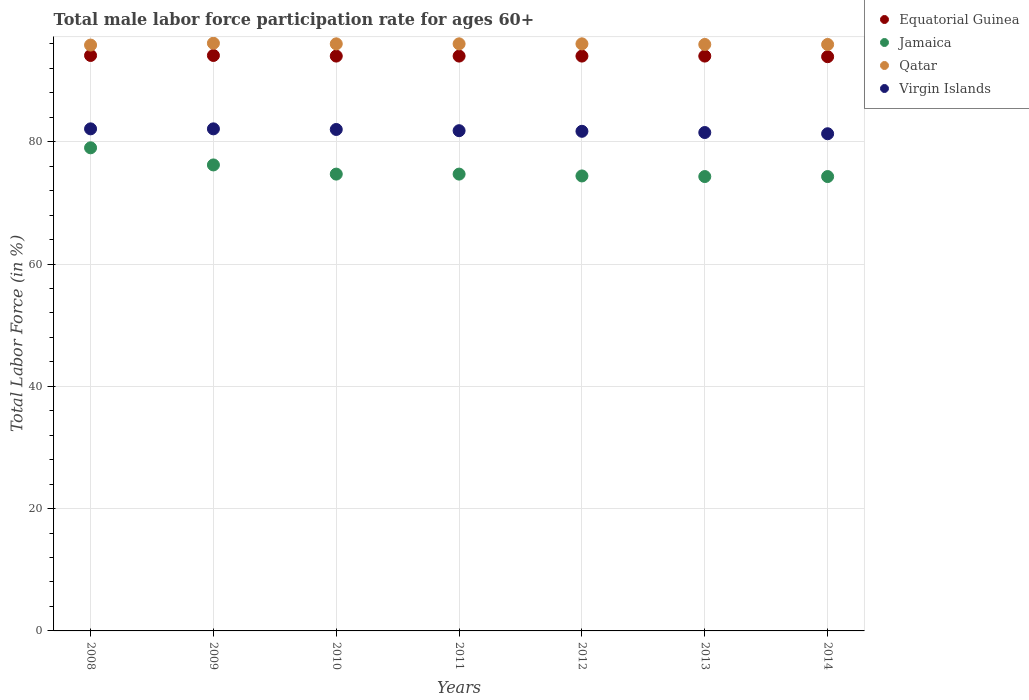How many different coloured dotlines are there?
Ensure brevity in your answer.  4. Is the number of dotlines equal to the number of legend labels?
Provide a short and direct response. Yes. What is the male labor force participation rate in Jamaica in 2013?
Your response must be concise. 74.3. Across all years, what is the maximum male labor force participation rate in Virgin Islands?
Offer a terse response. 82.1. Across all years, what is the minimum male labor force participation rate in Qatar?
Offer a very short reply. 95.8. In which year was the male labor force participation rate in Virgin Islands maximum?
Your answer should be very brief. 2008. What is the total male labor force participation rate in Qatar in the graph?
Offer a very short reply. 671.7. What is the difference between the male labor force participation rate in Virgin Islands in 2009 and that in 2011?
Keep it short and to the point. 0.3. What is the difference between the male labor force participation rate in Equatorial Guinea in 2014 and the male labor force participation rate in Jamaica in 2008?
Make the answer very short. 14.9. What is the average male labor force participation rate in Virgin Islands per year?
Make the answer very short. 81.79. What is the ratio of the male labor force participation rate in Qatar in 2008 to that in 2011?
Offer a very short reply. 1. What is the difference between the highest and the second highest male labor force participation rate in Jamaica?
Provide a short and direct response. 2.8. What is the difference between the highest and the lowest male labor force participation rate in Jamaica?
Give a very brief answer. 4.7. Is it the case that in every year, the sum of the male labor force participation rate in Qatar and male labor force participation rate in Equatorial Guinea  is greater than the sum of male labor force participation rate in Jamaica and male labor force participation rate in Virgin Islands?
Provide a short and direct response. Yes. Is it the case that in every year, the sum of the male labor force participation rate in Qatar and male labor force participation rate in Virgin Islands  is greater than the male labor force participation rate in Jamaica?
Your response must be concise. Yes. Is the male labor force participation rate in Equatorial Guinea strictly greater than the male labor force participation rate in Jamaica over the years?
Ensure brevity in your answer.  Yes. Is the male labor force participation rate in Virgin Islands strictly less than the male labor force participation rate in Jamaica over the years?
Your response must be concise. No. How many years are there in the graph?
Give a very brief answer. 7. How many legend labels are there?
Ensure brevity in your answer.  4. How are the legend labels stacked?
Offer a terse response. Vertical. What is the title of the graph?
Give a very brief answer. Total male labor force participation rate for ages 60+. What is the label or title of the X-axis?
Your answer should be compact. Years. What is the label or title of the Y-axis?
Your answer should be very brief. Total Labor Force (in %). What is the Total Labor Force (in %) in Equatorial Guinea in 2008?
Make the answer very short. 94.1. What is the Total Labor Force (in %) in Jamaica in 2008?
Your response must be concise. 79. What is the Total Labor Force (in %) in Qatar in 2008?
Ensure brevity in your answer.  95.8. What is the Total Labor Force (in %) of Virgin Islands in 2008?
Ensure brevity in your answer.  82.1. What is the Total Labor Force (in %) in Equatorial Guinea in 2009?
Provide a short and direct response. 94.1. What is the Total Labor Force (in %) of Jamaica in 2009?
Offer a terse response. 76.2. What is the Total Labor Force (in %) in Qatar in 2009?
Keep it short and to the point. 96.1. What is the Total Labor Force (in %) of Virgin Islands in 2009?
Offer a very short reply. 82.1. What is the Total Labor Force (in %) in Equatorial Guinea in 2010?
Provide a short and direct response. 94. What is the Total Labor Force (in %) of Jamaica in 2010?
Ensure brevity in your answer.  74.7. What is the Total Labor Force (in %) in Qatar in 2010?
Offer a very short reply. 96. What is the Total Labor Force (in %) in Equatorial Guinea in 2011?
Your answer should be very brief. 94. What is the Total Labor Force (in %) in Jamaica in 2011?
Ensure brevity in your answer.  74.7. What is the Total Labor Force (in %) in Qatar in 2011?
Your answer should be compact. 96. What is the Total Labor Force (in %) in Virgin Islands in 2011?
Give a very brief answer. 81.8. What is the Total Labor Force (in %) of Equatorial Guinea in 2012?
Your answer should be compact. 94. What is the Total Labor Force (in %) in Jamaica in 2012?
Keep it short and to the point. 74.4. What is the Total Labor Force (in %) of Qatar in 2012?
Your response must be concise. 96. What is the Total Labor Force (in %) of Virgin Islands in 2012?
Your answer should be compact. 81.7. What is the Total Labor Force (in %) of Equatorial Guinea in 2013?
Your answer should be compact. 94. What is the Total Labor Force (in %) in Jamaica in 2013?
Your answer should be compact. 74.3. What is the Total Labor Force (in %) in Qatar in 2013?
Give a very brief answer. 95.9. What is the Total Labor Force (in %) in Virgin Islands in 2013?
Your answer should be compact. 81.5. What is the Total Labor Force (in %) in Equatorial Guinea in 2014?
Ensure brevity in your answer.  93.9. What is the Total Labor Force (in %) of Jamaica in 2014?
Provide a succinct answer. 74.3. What is the Total Labor Force (in %) of Qatar in 2014?
Keep it short and to the point. 95.9. What is the Total Labor Force (in %) in Virgin Islands in 2014?
Make the answer very short. 81.3. Across all years, what is the maximum Total Labor Force (in %) in Equatorial Guinea?
Ensure brevity in your answer.  94.1. Across all years, what is the maximum Total Labor Force (in %) of Jamaica?
Ensure brevity in your answer.  79. Across all years, what is the maximum Total Labor Force (in %) in Qatar?
Provide a short and direct response. 96.1. Across all years, what is the maximum Total Labor Force (in %) in Virgin Islands?
Provide a short and direct response. 82.1. Across all years, what is the minimum Total Labor Force (in %) in Equatorial Guinea?
Keep it short and to the point. 93.9. Across all years, what is the minimum Total Labor Force (in %) of Jamaica?
Provide a succinct answer. 74.3. Across all years, what is the minimum Total Labor Force (in %) of Qatar?
Provide a succinct answer. 95.8. Across all years, what is the minimum Total Labor Force (in %) of Virgin Islands?
Provide a short and direct response. 81.3. What is the total Total Labor Force (in %) of Equatorial Guinea in the graph?
Your answer should be very brief. 658.1. What is the total Total Labor Force (in %) of Jamaica in the graph?
Provide a short and direct response. 527.6. What is the total Total Labor Force (in %) in Qatar in the graph?
Offer a very short reply. 671.7. What is the total Total Labor Force (in %) in Virgin Islands in the graph?
Offer a terse response. 572.5. What is the difference between the Total Labor Force (in %) in Jamaica in 2008 and that in 2009?
Your answer should be very brief. 2.8. What is the difference between the Total Labor Force (in %) of Qatar in 2008 and that in 2009?
Ensure brevity in your answer.  -0.3. What is the difference between the Total Labor Force (in %) of Equatorial Guinea in 2008 and that in 2010?
Offer a terse response. 0.1. What is the difference between the Total Labor Force (in %) in Jamaica in 2008 and that in 2010?
Give a very brief answer. 4.3. What is the difference between the Total Labor Force (in %) in Equatorial Guinea in 2008 and that in 2011?
Offer a terse response. 0.1. What is the difference between the Total Labor Force (in %) of Virgin Islands in 2008 and that in 2011?
Provide a succinct answer. 0.3. What is the difference between the Total Labor Force (in %) in Equatorial Guinea in 2008 and that in 2012?
Keep it short and to the point. 0.1. What is the difference between the Total Labor Force (in %) of Jamaica in 2008 and that in 2013?
Your response must be concise. 4.7. What is the difference between the Total Labor Force (in %) of Qatar in 2008 and that in 2013?
Ensure brevity in your answer.  -0.1. What is the difference between the Total Labor Force (in %) of Qatar in 2008 and that in 2014?
Ensure brevity in your answer.  -0.1. What is the difference between the Total Labor Force (in %) in Virgin Islands in 2008 and that in 2014?
Your response must be concise. 0.8. What is the difference between the Total Labor Force (in %) in Equatorial Guinea in 2009 and that in 2010?
Your response must be concise. 0.1. What is the difference between the Total Labor Force (in %) in Virgin Islands in 2009 and that in 2010?
Provide a succinct answer. 0.1. What is the difference between the Total Labor Force (in %) of Qatar in 2009 and that in 2011?
Ensure brevity in your answer.  0.1. What is the difference between the Total Labor Force (in %) in Virgin Islands in 2009 and that in 2011?
Ensure brevity in your answer.  0.3. What is the difference between the Total Labor Force (in %) of Jamaica in 2009 and that in 2012?
Offer a terse response. 1.8. What is the difference between the Total Labor Force (in %) of Equatorial Guinea in 2009 and that in 2013?
Provide a succinct answer. 0.1. What is the difference between the Total Labor Force (in %) of Qatar in 2009 and that in 2013?
Your answer should be very brief. 0.2. What is the difference between the Total Labor Force (in %) of Virgin Islands in 2009 and that in 2013?
Make the answer very short. 0.6. What is the difference between the Total Labor Force (in %) of Qatar in 2009 and that in 2014?
Provide a succinct answer. 0.2. What is the difference between the Total Labor Force (in %) in Virgin Islands in 2009 and that in 2014?
Make the answer very short. 0.8. What is the difference between the Total Labor Force (in %) in Equatorial Guinea in 2010 and that in 2011?
Give a very brief answer. 0. What is the difference between the Total Labor Force (in %) of Qatar in 2010 and that in 2011?
Make the answer very short. 0. What is the difference between the Total Labor Force (in %) in Virgin Islands in 2010 and that in 2011?
Ensure brevity in your answer.  0.2. What is the difference between the Total Labor Force (in %) of Equatorial Guinea in 2010 and that in 2012?
Give a very brief answer. 0. What is the difference between the Total Labor Force (in %) in Jamaica in 2010 and that in 2012?
Provide a short and direct response. 0.3. What is the difference between the Total Labor Force (in %) in Qatar in 2010 and that in 2012?
Your answer should be very brief. 0. What is the difference between the Total Labor Force (in %) in Virgin Islands in 2010 and that in 2012?
Give a very brief answer. 0.3. What is the difference between the Total Labor Force (in %) in Equatorial Guinea in 2010 and that in 2013?
Make the answer very short. 0. What is the difference between the Total Labor Force (in %) of Qatar in 2010 and that in 2013?
Make the answer very short. 0.1. What is the difference between the Total Labor Force (in %) in Jamaica in 2010 and that in 2014?
Your answer should be very brief. 0.4. What is the difference between the Total Labor Force (in %) of Virgin Islands in 2010 and that in 2014?
Provide a succinct answer. 0.7. What is the difference between the Total Labor Force (in %) of Jamaica in 2011 and that in 2012?
Your answer should be compact. 0.3. What is the difference between the Total Labor Force (in %) in Jamaica in 2011 and that in 2013?
Keep it short and to the point. 0.4. What is the difference between the Total Labor Force (in %) in Qatar in 2011 and that in 2013?
Offer a terse response. 0.1. What is the difference between the Total Labor Force (in %) in Qatar in 2011 and that in 2014?
Make the answer very short. 0.1. What is the difference between the Total Labor Force (in %) of Equatorial Guinea in 2012 and that in 2013?
Provide a succinct answer. 0. What is the difference between the Total Labor Force (in %) in Jamaica in 2012 and that in 2013?
Your answer should be very brief. 0.1. What is the difference between the Total Labor Force (in %) of Virgin Islands in 2012 and that in 2013?
Give a very brief answer. 0.2. What is the difference between the Total Labor Force (in %) in Equatorial Guinea in 2012 and that in 2014?
Provide a short and direct response. 0.1. What is the difference between the Total Labor Force (in %) in Virgin Islands in 2012 and that in 2014?
Ensure brevity in your answer.  0.4. What is the difference between the Total Labor Force (in %) in Equatorial Guinea in 2013 and that in 2014?
Keep it short and to the point. 0.1. What is the difference between the Total Labor Force (in %) in Jamaica in 2013 and that in 2014?
Your answer should be compact. 0. What is the difference between the Total Labor Force (in %) of Equatorial Guinea in 2008 and the Total Labor Force (in %) of Qatar in 2009?
Provide a succinct answer. -2. What is the difference between the Total Labor Force (in %) in Equatorial Guinea in 2008 and the Total Labor Force (in %) in Virgin Islands in 2009?
Provide a succinct answer. 12. What is the difference between the Total Labor Force (in %) in Jamaica in 2008 and the Total Labor Force (in %) in Qatar in 2009?
Offer a very short reply. -17.1. What is the difference between the Total Labor Force (in %) of Jamaica in 2008 and the Total Labor Force (in %) of Virgin Islands in 2009?
Provide a short and direct response. -3.1. What is the difference between the Total Labor Force (in %) of Equatorial Guinea in 2008 and the Total Labor Force (in %) of Jamaica in 2010?
Your response must be concise. 19.4. What is the difference between the Total Labor Force (in %) of Equatorial Guinea in 2008 and the Total Labor Force (in %) of Virgin Islands in 2010?
Give a very brief answer. 12.1. What is the difference between the Total Labor Force (in %) in Jamaica in 2008 and the Total Labor Force (in %) in Virgin Islands in 2011?
Your answer should be compact. -2.8. What is the difference between the Total Labor Force (in %) of Equatorial Guinea in 2008 and the Total Labor Force (in %) of Jamaica in 2013?
Offer a very short reply. 19.8. What is the difference between the Total Labor Force (in %) in Equatorial Guinea in 2008 and the Total Labor Force (in %) in Virgin Islands in 2013?
Offer a terse response. 12.6. What is the difference between the Total Labor Force (in %) of Jamaica in 2008 and the Total Labor Force (in %) of Qatar in 2013?
Give a very brief answer. -16.9. What is the difference between the Total Labor Force (in %) in Equatorial Guinea in 2008 and the Total Labor Force (in %) in Jamaica in 2014?
Your response must be concise. 19.8. What is the difference between the Total Labor Force (in %) of Equatorial Guinea in 2008 and the Total Labor Force (in %) of Qatar in 2014?
Ensure brevity in your answer.  -1.8. What is the difference between the Total Labor Force (in %) in Equatorial Guinea in 2008 and the Total Labor Force (in %) in Virgin Islands in 2014?
Give a very brief answer. 12.8. What is the difference between the Total Labor Force (in %) in Jamaica in 2008 and the Total Labor Force (in %) in Qatar in 2014?
Your answer should be very brief. -16.9. What is the difference between the Total Labor Force (in %) of Equatorial Guinea in 2009 and the Total Labor Force (in %) of Jamaica in 2010?
Provide a short and direct response. 19.4. What is the difference between the Total Labor Force (in %) in Equatorial Guinea in 2009 and the Total Labor Force (in %) in Virgin Islands in 2010?
Make the answer very short. 12.1. What is the difference between the Total Labor Force (in %) in Jamaica in 2009 and the Total Labor Force (in %) in Qatar in 2010?
Make the answer very short. -19.8. What is the difference between the Total Labor Force (in %) in Equatorial Guinea in 2009 and the Total Labor Force (in %) in Jamaica in 2011?
Make the answer very short. 19.4. What is the difference between the Total Labor Force (in %) of Jamaica in 2009 and the Total Labor Force (in %) of Qatar in 2011?
Offer a very short reply. -19.8. What is the difference between the Total Labor Force (in %) of Equatorial Guinea in 2009 and the Total Labor Force (in %) of Virgin Islands in 2012?
Provide a succinct answer. 12.4. What is the difference between the Total Labor Force (in %) in Jamaica in 2009 and the Total Labor Force (in %) in Qatar in 2012?
Your answer should be very brief. -19.8. What is the difference between the Total Labor Force (in %) of Jamaica in 2009 and the Total Labor Force (in %) of Virgin Islands in 2012?
Your answer should be compact. -5.5. What is the difference between the Total Labor Force (in %) in Equatorial Guinea in 2009 and the Total Labor Force (in %) in Jamaica in 2013?
Keep it short and to the point. 19.8. What is the difference between the Total Labor Force (in %) in Jamaica in 2009 and the Total Labor Force (in %) in Qatar in 2013?
Give a very brief answer. -19.7. What is the difference between the Total Labor Force (in %) of Jamaica in 2009 and the Total Labor Force (in %) of Virgin Islands in 2013?
Make the answer very short. -5.3. What is the difference between the Total Labor Force (in %) in Qatar in 2009 and the Total Labor Force (in %) in Virgin Islands in 2013?
Offer a very short reply. 14.6. What is the difference between the Total Labor Force (in %) of Equatorial Guinea in 2009 and the Total Labor Force (in %) of Jamaica in 2014?
Your answer should be very brief. 19.8. What is the difference between the Total Labor Force (in %) in Equatorial Guinea in 2009 and the Total Labor Force (in %) in Qatar in 2014?
Your response must be concise. -1.8. What is the difference between the Total Labor Force (in %) in Jamaica in 2009 and the Total Labor Force (in %) in Qatar in 2014?
Give a very brief answer. -19.7. What is the difference between the Total Labor Force (in %) of Jamaica in 2009 and the Total Labor Force (in %) of Virgin Islands in 2014?
Ensure brevity in your answer.  -5.1. What is the difference between the Total Labor Force (in %) of Equatorial Guinea in 2010 and the Total Labor Force (in %) of Jamaica in 2011?
Your answer should be compact. 19.3. What is the difference between the Total Labor Force (in %) of Equatorial Guinea in 2010 and the Total Labor Force (in %) of Qatar in 2011?
Make the answer very short. -2. What is the difference between the Total Labor Force (in %) in Equatorial Guinea in 2010 and the Total Labor Force (in %) in Virgin Islands in 2011?
Give a very brief answer. 12.2. What is the difference between the Total Labor Force (in %) of Jamaica in 2010 and the Total Labor Force (in %) of Qatar in 2011?
Your answer should be very brief. -21.3. What is the difference between the Total Labor Force (in %) of Jamaica in 2010 and the Total Labor Force (in %) of Virgin Islands in 2011?
Make the answer very short. -7.1. What is the difference between the Total Labor Force (in %) in Qatar in 2010 and the Total Labor Force (in %) in Virgin Islands in 2011?
Make the answer very short. 14.2. What is the difference between the Total Labor Force (in %) in Equatorial Guinea in 2010 and the Total Labor Force (in %) in Jamaica in 2012?
Your answer should be compact. 19.6. What is the difference between the Total Labor Force (in %) of Equatorial Guinea in 2010 and the Total Labor Force (in %) of Qatar in 2012?
Offer a very short reply. -2. What is the difference between the Total Labor Force (in %) of Jamaica in 2010 and the Total Labor Force (in %) of Qatar in 2012?
Keep it short and to the point. -21.3. What is the difference between the Total Labor Force (in %) of Equatorial Guinea in 2010 and the Total Labor Force (in %) of Qatar in 2013?
Ensure brevity in your answer.  -1.9. What is the difference between the Total Labor Force (in %) in Jamaica in 2010 and the Total Labor Force (in %) in Qatar in 2013?
Ensure brevity in your answer.  -21.2. What is the difference between the Total Labor Force (in %) of Equatorial Guinea in 2010 and the Total Labor Force (in %) of Qatar in 2014?
Provide a short and direct response. -1.9. What is the difference between the Total Labor Force (in %) of Jamaica in 2010 and the Total Labor Force (in %) of Qatar in 2014?
Give a very brief answer. -21.2. What is the difference between the Total Labor Force (in %) of Qatar in 2010 and the Total Labor Force (in %) of Virgin Islands in 2014?
Offer a very short reply. 14.7. What is the difference between the Total Labor Force (in %) in Equatorial Guinea in 2011 and the Total Labor Force (in %) in Jamaica in 2012?
Make the answer very short. 19.6. What is the difference between the Total Labor Force (in %) of Equatorial Guinea in 2011 and the Total Labor Force (in %) of Qatar in 2012?
Ensure brevity in your answer.  -2. What is the difference between the Total Labor Force (in %) in Equatorial Guinea in 2011 and the Total Labor Force (in %) in Virgin Islands in 2012?
Give a very brief answer. 12.3. What is the difference between the Total Labor Force (in %) of Jamaica in 2011 and the Total Labor Force (in %) of Qatar in 2012?
Ensure brevity in your answer.  -21.3. What is the difference between the Total Labor Force (in %) of Jamaica in 2011 and the Total Labor Force (in %) of Virgin Islands in 2012?
Ensure brevity in your answer.  -7. What is the difference between the Total Labor Force (in %) in Qatar in 2011 and the Total Labor Force (in %) in Virgin Islands in 2012?
Your response must be concise. 14.3. What is the difference between the Total Labor Force (in %) in Equatorial Guinea in 2011 and the Total Labor Force (in %) in Qatar in 2013?
Provide a succinct answer. -1.9. What is the difference between the Total Labor Force (in %) in Equatorial Guinea in 2011 and the Total Labor Force (in %) in Virgin Islands in 2013?
Your response must be concise. 12.5. What is the difference between the Total Labor Force (in %) in Jamaica in 2011 and the Total Labor Force (in %) in Qatar in 2013?
Provide a short and direct response. -21.2. What is the difference between the Total Labor Force (in %) in Equatorial Guinea in 2011 and the Total Labor Force (in %) in Jamaica in 2014?
Make the answer very short. 19.7. What is the difference between the Total Labor Force (in %) of Jamaica in 2011 and the Total Labor Force (in %) of Qatar in 2014?
Give a very brief answer. -21.2. What is the difference between the Total Labor Force (in %) in Equatorial Guinea in 2012 and the Total Labor Force (in %) in Qatar in 2013?
Keep it short and to the point. -1.9. What is the difference between the Total Labor Force (in %) in Jamaica in 2012 and the Total Labor Force (in %) in Qatar in 2013?
Offer a terse response. -21.5. What is the difference between the Total Labor Force (in %) in Equatorial Guinea in 2012 and the Total Labor Force (in %) in Qatar in 2014?
Offer a terse response. -1.9. What is the difference between the Total Labor Force (in %) of Equatorial Guinea in 2012 and the Total Labor Force (in %) of Virgin Islands in 2014?
Your answer should be compact. 12.7. What is the difference between the Total Labor Force (in %) of Jamaica in 2012 and the Total Labor Force (in %) of Qatar in 2014?
Ensure brevity in your answer.  -21.5. What is the difference between the Total Labor Force (in %) in Jamaica in 2012 and the Total Labor Force (in %) in Virgin Islands in 2014?
Make the answer very short. -6.9. What is the difference between the Total Labor Force (in %) in Qatar in 2012 and the Total Labor Force (in %) in Virgin Islands in 2014?
Your response must be concise. 14.7. What is the difference between the Total Labor Force (in %) of Equatorial Guinea in 2013 and the Total Labor Force (in %) of Jamaica in 2014?
Offer a very short reply. 19.7. What is the difference between the Total Labor Force (in %) of Jamaica in 2013 and the Total Labor Force (in %) of Qatar in 2014?
Provide a short and direct response. -21.6. What is the average Total Labor Force (in %) of Equatorial Guinea per year?
Offer a terse response. 94.01. What is the average Total Labor Force (in %) of Jamaica per year?
Offer a terse response. 75.37. What is the average Total Labor Force (in %) in Qatar per year?
Your response must be concise. 95.96. What is the average Total Labor Force (in %) in Virgin Islands per year?
Your answer should be very brief. 81.79. In the year 2008, what is the difference between the Total Labor Force (in %) of Equatorial Guinea and Total Labor Force (in %) of Qatar?
Your answer should be very brief. -1.7. In the year 2008, what is the difference between the Total Labor Force (in %) in Equatorial Guinea and Total Labor Force (in %) in Virgin Islands?
Make the answer very short. 12. In the year 2008, what is the difference between the Total Labor Force (in %) of Jamaica and Total Labor Force (in %) of Qatar?
Your response must be concise. -16.8. In the year 2008, what is the difference between the Total Labor Force (in %) in Jamaica and Total Labor Force (in %) in Virgin Islands?
Offer a terse response. -3.1. In the year 2009, what is the difference between the Total Labor Force (in %) in Jamaica and Total Labor Force (in %) in Qatar?
Give a very brief answer. -19.9. In the year 2010, what is the difference between the Total Labor Force (in %) of Equatorial Guinea and Total Labor Force (in %) of Jamaica?
Your answer should be compact. 19.3. In the year 2010, what is the difference between the Total Labor Force (in %) of Jamaica and Total Labor Force (in %) of Qatar?
Keep it short and to the point. -21.3. In the year 2010, what is the difference between the Total Labor Force (in %) of Jamaica and Total Labor Force (in %) of Virgin Islands?
Provide a succinct answer. -7.3. In the year 2010, what is the difference between the Total Labor Force (in %) of Qatar and Total Labor Force (in %) of Virgin Islands?
Offer a terse response. 14. In the year 2011, what is the difference between the Total Labor Force (in %) of Equatorial Guinea and Total Labor Force (in %) of Jamaica?
Your answer should be very brief. 19.3. In the year 2011, what is the difference between the Total Labor Force (in %) of Equatorial Guinea and Total Labor Force (in %) of Virgin Islands?
Provide a succinct answer. 12.2. In the year 2011, what is the difference between the Total Labor Force (in %) in Jamaica and Total Labor Force (in %) in Qatar?
Offer a very short reply. -21.3. In the year 2011, what is the difference between the Total Labor Force (in %) of Qatar and Total Labor Force (in %) of Virgin Islands?
Offer a very short reply. 14.2. In the year 2012, what is the difference between the Total Labor Force (in %) of Equatorial Guinea and Total Labor Force (in %) of Jamaica?
Give a very brief answer. 19.6. In the year 2012, what is the difference between the Total Labor Force (in %) of Equatorial Guinea and Total Labor Force (in %) of Virgin Islands?
Your answer should be very brief. 12.3. In the year 2012, what is the difference between the Total Labor Force (in %) of Jamaica and Total Labor Force (in %) of Qatar?
Provide a short and direct response. -21.6. In the year 2012, what is the difference between the Total Labor Force (in %) of Qatar and Total Labor Force (in %) of Virgin Islands?
Your answer should be compact. 14.3. In the year 2013, what is the difference between the Total Labor Force (in %) in Equatorial Guinea and Total Labor Force (in %) in Jamaica?
Your response must be concise. 19.7. In the year 2013, what is the difference between the Total Labor Force (in %) in Equatorial Guinea and Total Labor Force (in %) in Qatar?
Offer a terse response. -1.9. In the year 2013, what is the difference between the Total Labor Force (in %) of Equatorial Guinea and Total Labor Force (in %) of Virgin Islands?
Ensure brevity in your answer.  12.5. In the year 2013, what is the difference between the Total Labor Force (in %) of Jamaica and Total Labor Force (in %) of Qatar?
Provide a succinct answer. -21.6. In the year 2014, what is the difference between the Total Labor Force (in %) of Equatorial Guinea and Total Labor Force (in %) of Jamaica?
Your response must be concise. 19.6. In the year 2014, what is the difference between the Total Labor Force (in %) of Equatorial Guinea and Total Labor Force (in %) of Virgin Islands?
Your response must be concise. 12.6. In the year 2014, what is the difference between the Total Labor Force (in %) of Jamaica and Total Labor Force (in %) of Qatar?
Offer a terse response. -21.6. In the year 2014, what is the difference between the Total Labor Force (in %) in Jamaica and Total Labor Force (in %) in Virgin Islands?
Offer a very short reply. -7. In the year 2014, what is the difference between the Total Labor Force (in %) of Qatar and Total Labor Force (in %) of Virgin Islands?
Make the answer very short. 14.6. What is the ratio of the Total Labor Force (in %) of Jamaica in 2008 to that in 2009?
Give a very brief answer. 1.04. What is the ratio of the Total Labor Force (in %) in Qatar in 2008 to that in 2009?
Keep it short and to the point. 1. What is the ratio of the Total Labor Force (in %) in Virgin Islands in 2008 to that in 2009?
Make the answer very short. 1. What is the ratio of the Total Labor Force (in %) of Jamaica in 2008 to that in 2010?
Give a very brief answer. 1.06. What is the ratio of the Total Labor Force (in %) in Virgin Islands in 2008 to that in 2010?
Your answer should be compact. 1. What is the ratio of the Total Labor Force (in %) of Equatorial Guinea in 2008 to that in 2011?
Your response must be concise. 1. What is the ratio of the Total Labor Force (in %) of Jamaica in 2008 to that in 2011?
Your answer should be very brief. 1.06. What is the ratio of the Total Labor Force (in %) of Qatar in 2008 to that in 2011?
Make the answer very short. 1. What is the ratio of the Total Labor Force (in %) of Virgin Islands in 2008 to that in 2011?
Ensure brevity in your answer.  1. What is the ratio of the Total Labor Force (in %) of Equatorial Guinea in 2008 to that in 2012?
Your answer should be compact. 1. What is the ratio of the Total Labor Force (in %) in Jamaica in 2008 to that in 2012?
Ensure brevity in your answer.  1.06. What is the ratio of the Total Labor Force (in %) in Qatar in 2008 to that in 2012?
Make the answer very short. 1. What is the ratio of the Total Labor Force (in %) of Virgin Islands in 2008 to that in 2012?
Provide a succinct answer. 1. What is the ratio of the Total Labor Force (in %) of Equatorial Guinea in 2008 to that in 2013?
Offer a very short reply. 1. What is the ratio of the Total Labor Force (in %) of Jamaica in 2008 to that in 2013?
Your answer should be compact. 1.06. What is the ratio of the Total Labor Force (in %) in Qatar in 2008 to that in 2013?
Keep it short and to the point. 1. What is the ratio of the Total Labor Force (in %) in Virgin Islands in 2008 to that in 2013?
Your answer should be very brief. 1.01. What is the ratio of the Total Labor Force (in %) in Jamaica in 2008 to that in 2014?
Offer a very short reply. 1.06. What is the ratio of the Total Labor Force (in %) of Virgin Islands in 2008 to that in 2014?
Ensure brevity in your answer.  1.01. What is the ratio of the Total Labor Force (in %) in Equatorial Guinea in 2009 to that in 2010?
Offer a terse response. 1. What is the ratio of the Total Labor Force (in %) in Jamaica in 2009 to that in 2010?
Provide a succinct answer. 1.02. What is the ratio of the Total Labor Force (in %) in Equatorial Guinea in 2009 to that in 2011?
Make the answer very short. 1. What is the ratio of the Total Labor Force (in %) in Jamaica in 2009 to that in 2011?
Make the answer very short. 1.02. What is the ratio of the Total Labor Force (in %) of Qatar in 2009 to that in 2011?
Your answer should be very brief. 1. What is the ratio of the Total Labor Force (in %) of Virgin Islands in 2009 to that in 2011?
Ensure brevity in your answer.  1. What is the ratio of the Total Labor Force (in %) in Jamaica in 2009 to that in 2012?
Your answer should be very brief. 1.02. What is the ratio of the Total Labor Force (in %) of Qatar in 2009 to that in 2012?
Offer a very short reply. 1. What is the ratio of the Total Labor Force (in %) in Virgin Islands in 2009 to that in 2012?
Give a very brief answer. 1. What is the ratio of the Total Labor Force (in %) of Jamaica in 2009 to that in 2013?
Make the answer very short. 1.03. What is the ratio of the Total Labor Force (in %) in Virgin Islands in 2009 to that in 2013?
Provide a succinct answer. 1.01. What is the ratio of the Total Labor Force (in %) of Jamaica in 2009 to that in 2014?
Provide a short and direct response. 1.03. What is the ratio of the Total Labor Force (in %) of Qatar in 2009 to that in 2014?
Keep it short and to the point. 1. What is the ratio of the Total Labor Force (in %) in Virgin Islands in 2009 to that in 2014?
Keep it short and to the point. 1.01. What is the ratio of the Total Labor Force (in %) in Equatorial Guinea in 2010 to that in 2011?
Your answer should be compact. 1. What is the ratio of the Total Labor Force (in %) in Jamaica in 2010 to that in 2011?
Offer a very short reply. 1. What is the ratio of the Total Labor Force (in %) of Virgin Islands in 2010 to that in 2011?
Give a very brief answer. 1. What is the ratio of the Total Labor Force (in %) of Equatorial Guinea in 2010 to that in 2012?
Your answer should be compact. 1. What is the ratio of the Total Labor Force (in %) in Virgin Islands in 2010 to that in 2012?
Offer a very short reply. 1. What is the ratio of the Total Labor Force (in %) in Jamaica in 2010 to that in 2013?
Give a very brief answer. 1.01. What is the ratio of the Total Labor Force (in %) in Virgin Islands in 2010 to that in 2013?
Offer a terse response. 1.01. What is the ratio of the Total Labor Force (in %) of Jamaica in 2010 to that in 2014?
Your response must be concise. 1.01. What is the ratio of the Total Labor Force (in %) of Virgin Islands in 2010 to that in 2014?
Give a very brief answer. 1.01. What is the ratio of the Total Labor Force (in %) in Virgin Islands in 2011 to that in 2012?
Offer a very short reply. 1. What is the ratio of the Total Labor Force (in %) in Jamaica in 2011 to that in 2013?
Offer a terse response. 1.01. What is the ratio of the Total Labor Force (in %) in Qatar in 2011 to that in 2013?
Keep it short and to the point. 1. What is the ratio of the Total Labor Force (in %) in Virgin Islands in 2011 to that in 2013?
Your answer should be very brief. 1. What is the ratio of the Total Labor Force (in %) of Jamaica in 2011 to that in 2014?
Make the answer very short. 1.01. What is the ratio of the Total Labor Force (in %) in Qatar in 2012 to that in 2013?
Your answer should be very brief. 1. What is the ratio of the Total Labor Force (in %) in Jamaica in 2012 to that in 2014?
Your answer should be compact. 1. What is the ratio of the Total Labor Force (in %) of Equatorial Guinea in 2013 to that in 2014?
Your response must be concise. 1. What is the ratio of the Total Labor Force (in %) in Jamaica in 2013 to that in 2014?
Provide a succinct answer. 1. What is the difference between the highest and the second highest Total Labor Force (in %) of Qatar?
Offer a terse response. 0.1. What is the difference between the highest and the lowest Total Labor Force (in %) of Equatorial Guinea?
Keep it short and to the point. 0.2. What is the difference between the highest and the lowest Total Labor Force (in %) of Qatar?
Make the answer very short. 0.3. 